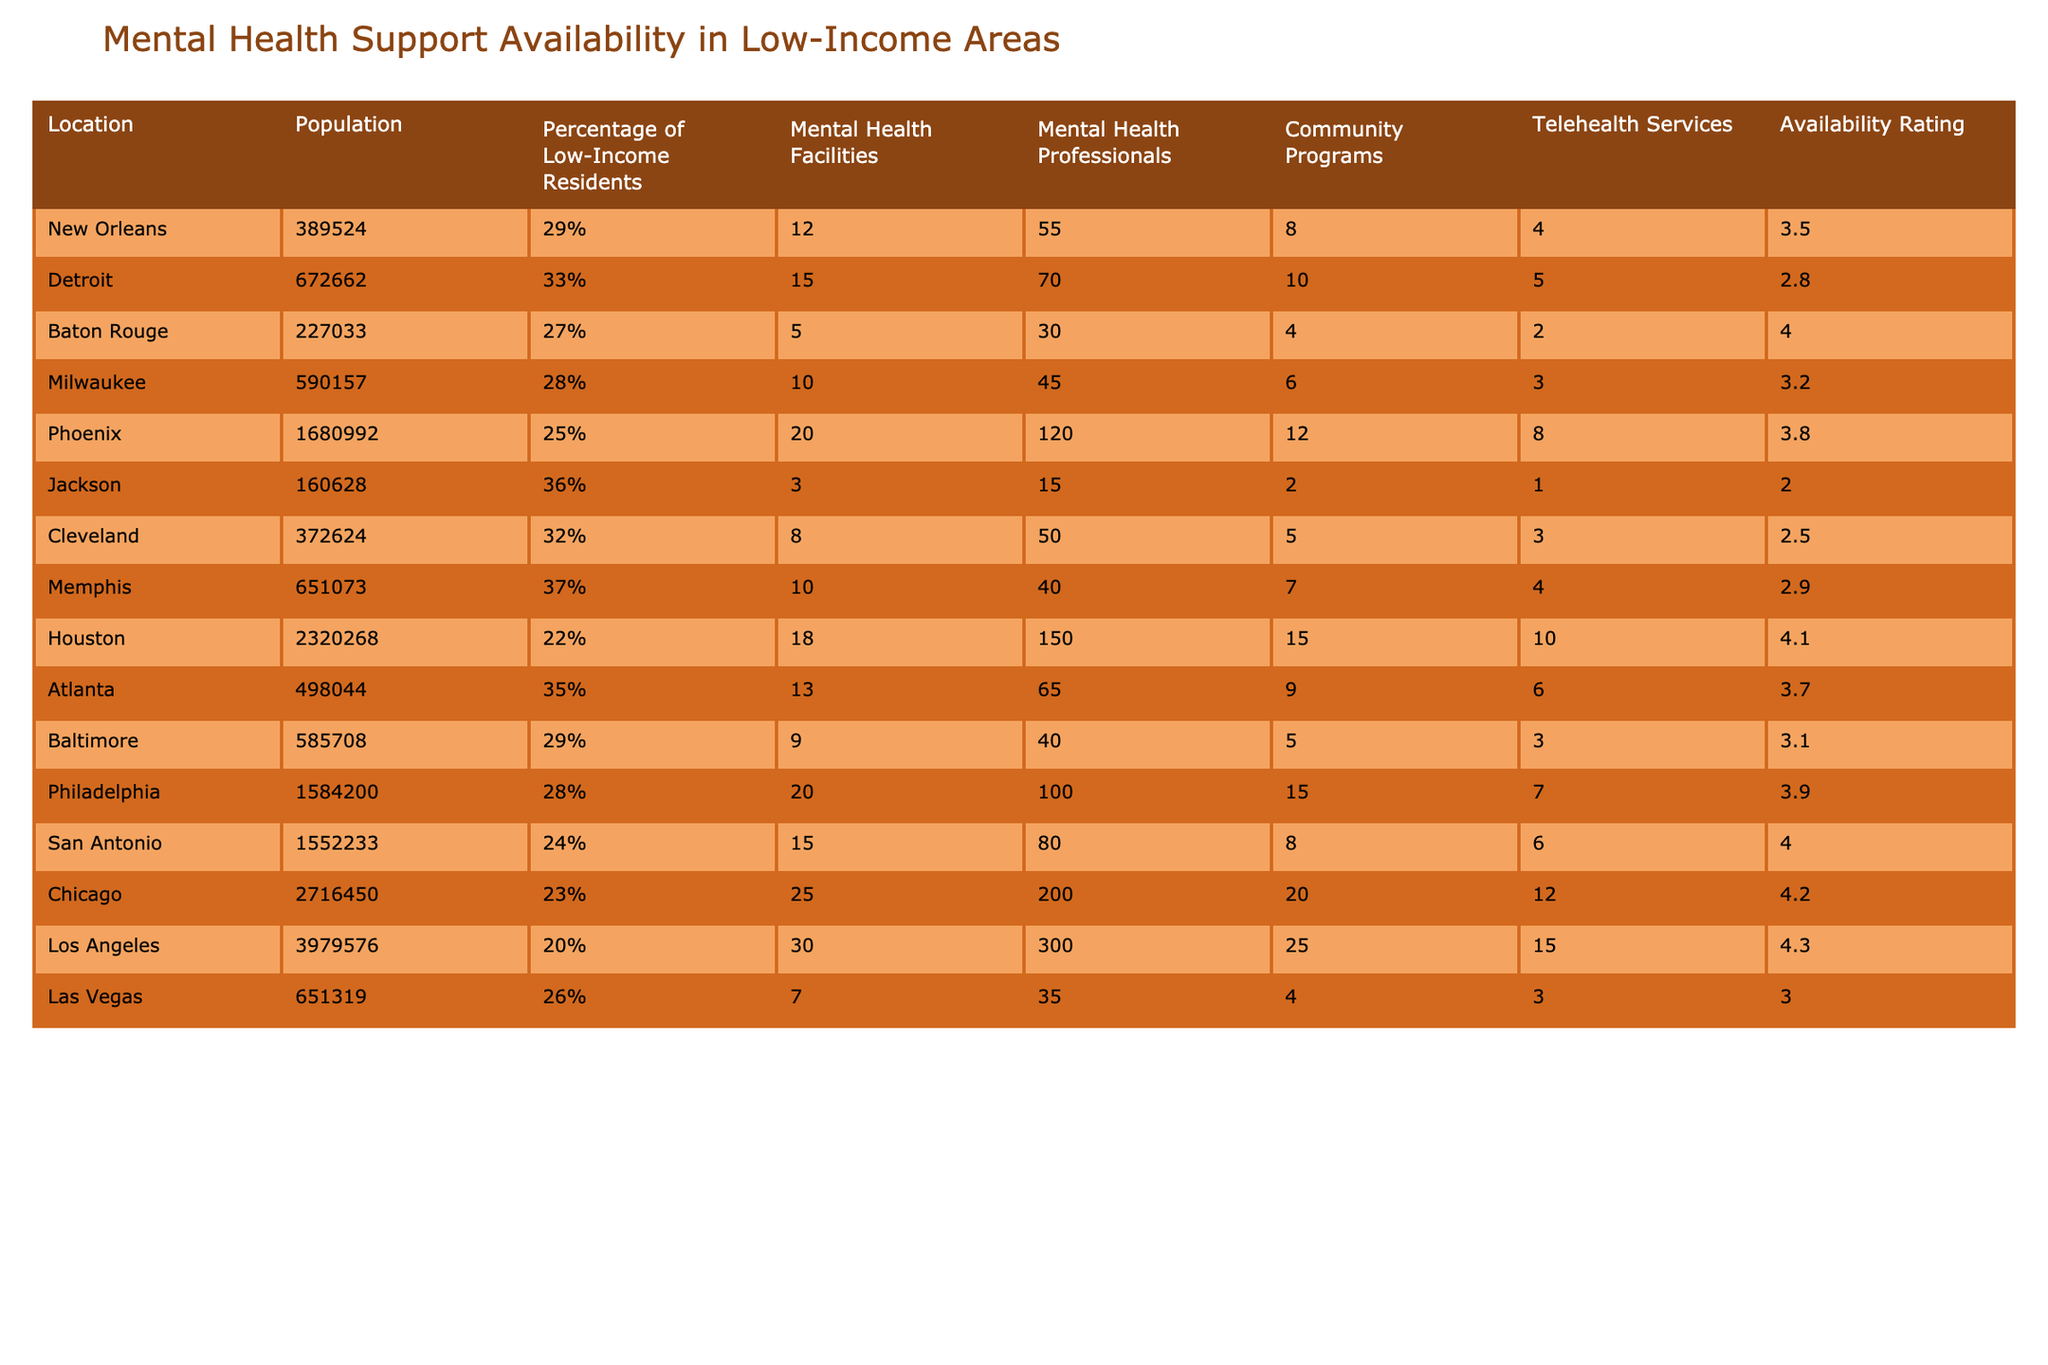What city has the highest availability rating for mental health support? By examining the "Availability Rating" column, I can see that Houston has the highest value at 4.1.
Answer: Houston Which location has the least number of mental health facilities? Looking at the "Mental Health Facilities" column, I find that Jackson has the lowest count with only 3 facilities.
Answer: Jackson What is the average percentage of low-income residents across all locations? To find the average percentage, I sum the percentages (29% + 33% + 27% + 28% + 25% + 36% + 32% + 37% + 22% + 35% + 29% + 28% + 24% + 23% + 20% + 26%) resulting in  495%. Dividing by the number of locations (16) gives an average of approximately 30.94%.
Answer: Approximately 30.94% Is there a location with more mental health professionals than facilities? I compare the "Mental Health Professionals" and "Mental Health Facilities" columns; I see that both Houston (150 professionals, 18 facilities) and Chicago (200 professionals, 25 facilities) meet this condition.
Answer: Yes, Houston and Chicago Which two cities have the highest combined number of community programs? I look at the "Community Programs" column: Houston (15) and Chicago (20) have the highest totals. Adding these, 15 + 20 = 35.
Answer: Houston and Chicago What percentage of residents in Milwaukee are low-income? Checking the "Percentage of Low-Income Residents" column, I find it is 28%.
Answer: 28% Which city offers telehealth services but does not have community programs? In the table, only Jackson has telehealth services (1) and no community programs listed.
Answer: Jackson Do more mental health facilities correlate with higher availability ratings? While examining both columns, I note that Detroit has 15 facilities and a low availability rating of 2.8. Meanwhile, Houston has 18 facilities but a much higher rating of 4.1, indicating a more complex relationship, suggesting not always a direct correlation exists.
Answer: No, it's not always correlated What is the total number of mental health facilities across all cities? I sum the "Mental Health Facilities" column values (12 + 15 + 5 + 10 + 20 + 3 + 8 + 10 + 18 + 13 + 9 + 20 + 15 + 25 + 30 + 7) to get a total of  274.
Answer: 274 How many cities have an availability rating lower than 3? I check the "Availability Rating" column and find that there are 5 cities—Detroit (2.8), Jackson (2.0), Cleveland (2.5), Memphis (2.9) and Las Vegas (3.0) with ratings below 3.
Answer: 5 cities Which location has the highest population to mental health professional ratio? I calculate the ratio of population to professionals for each city. For example, in Houston, the ratio is 2320268 / 150 = 15468. This ratio is highest for the location with the least number of professionals, Jackson (160628 / 15 = 10709). The city with the highest ratio is Cleveland (372624 / 50 = 7452). After comparing all, Jackson has the highest ratio.
Answer: Jackson 